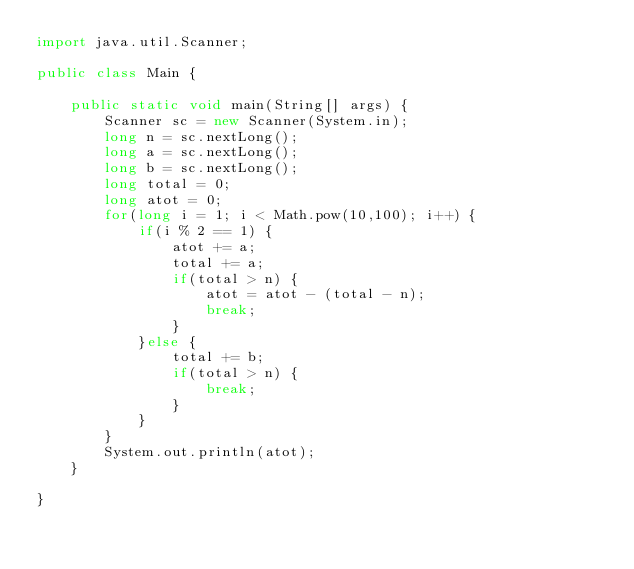<code> <loc_0><loc_0><loc_500><loc_500><_Java_>import java.util.Scanner;

public class Main {

	public static void main(String[] args) {
		Scanner sc = new Scanner(System.in);
		long n = sc.nextLong();
		long a = sc.nextLong();
		long b = sc.nextLong();
		long total = 0;
		long atot = 0;
		for(long i = 1; i < Math.pow(10,100); i++) {
			if(i % 2 == 1) {
				atot += a;
				total += a;
				if(total > n) {
					atot = atot - (total - n);
					break;
				}
			}else {
				total += b;
				if(total > n) {
					break;
				}
			}
		}
		System.out.println(atot);
	}

}</code> 